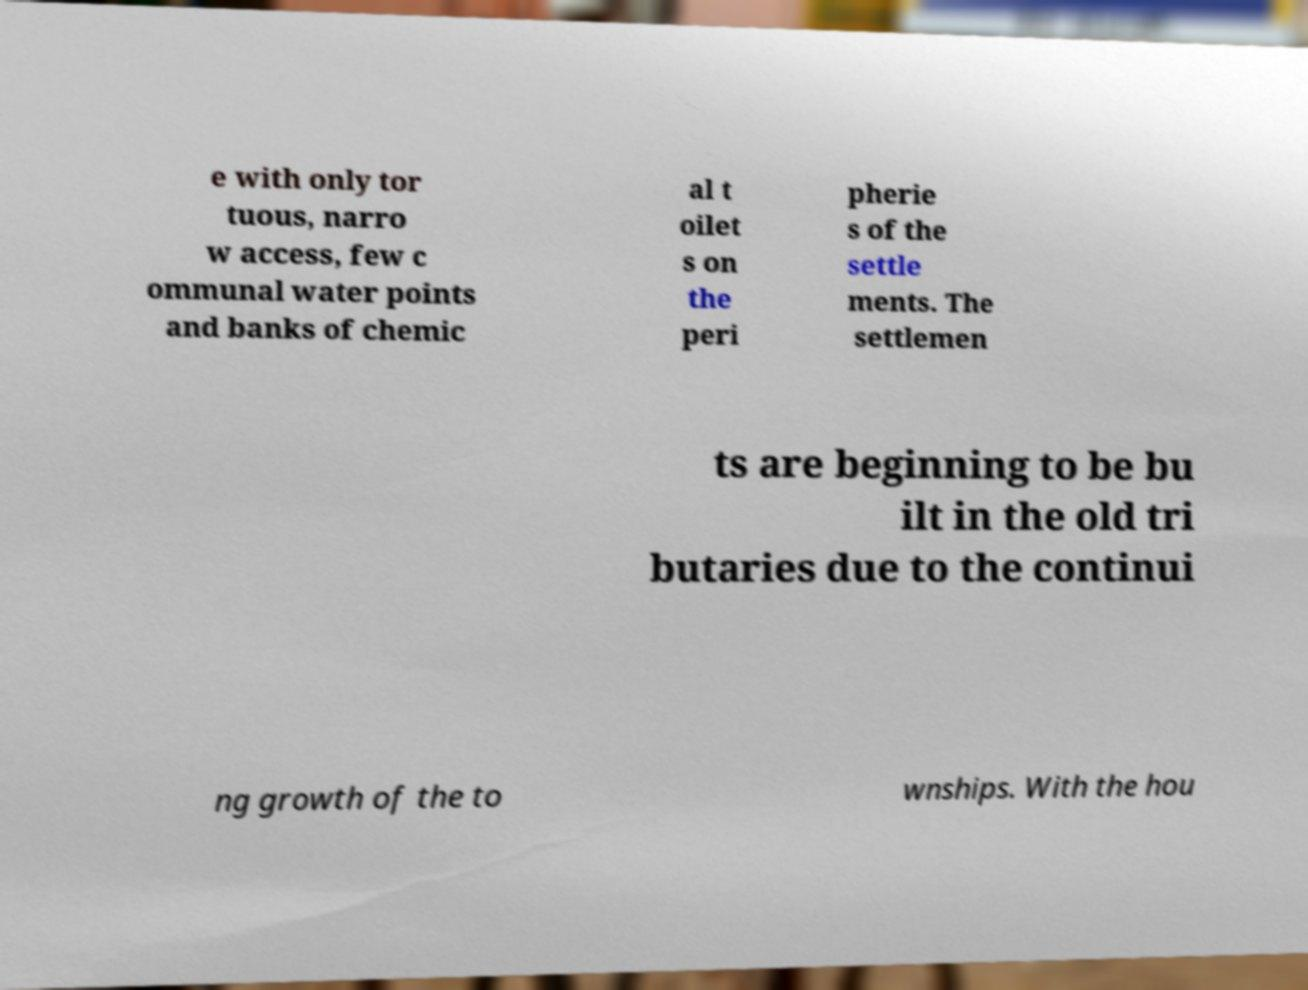Can you read and provide the text displayed in the image?This photo seems to have some interesting text. Can you extract and type it out for me? e with only tor tuous, narro w access, few c ommunal water points and banks of chemic al t oilet s on the peri pherie s of the settle ments. The settlemen ts are beginning to be bu ilt in the old tri butaries due to the continui ng growth of the to wnships. With the hou 